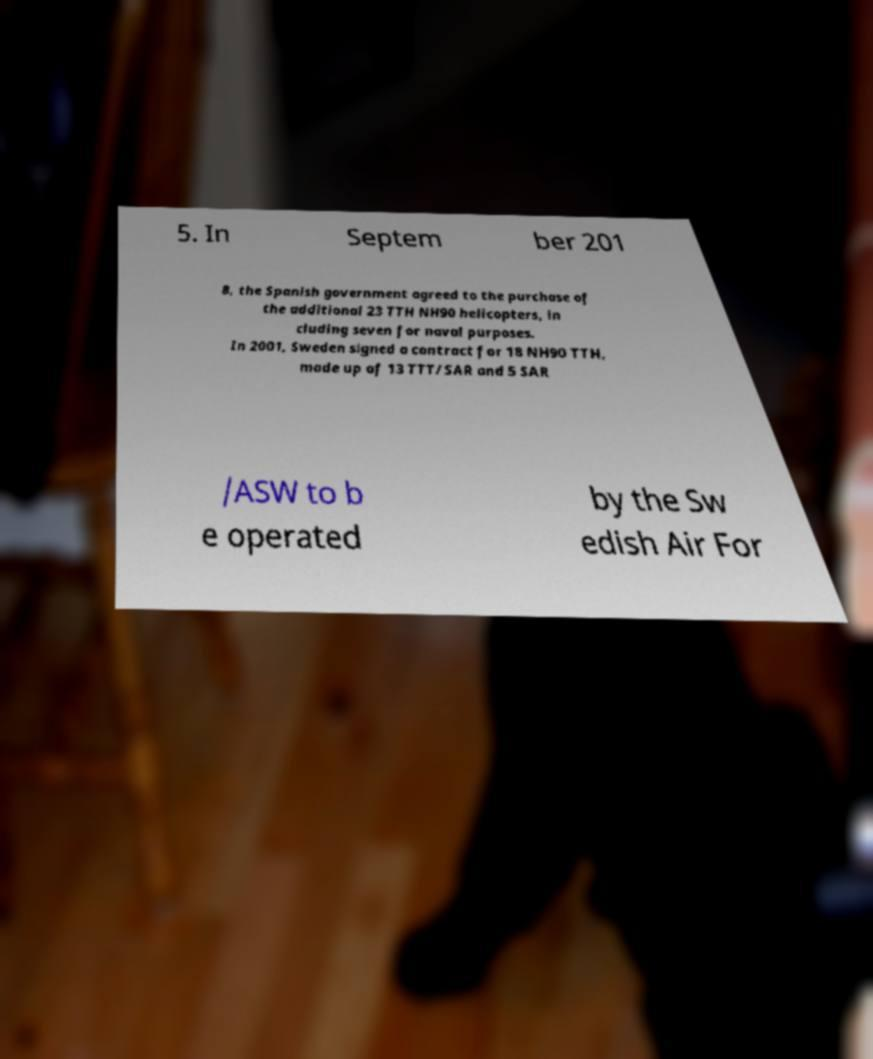Please identify and transcribe the text found in this image. 5. In Septem ber 201 8, the Spanish government agreed to the purchase of the additional 23 TTH NH90 helicopters, in cluding seven for naval purposes. In 2001, Sweden signed a contract for 18 NH90 TTH, made up of 13 TTT/SAR and 5 SAR /ASW to b e operated by the Sw edish Air For 